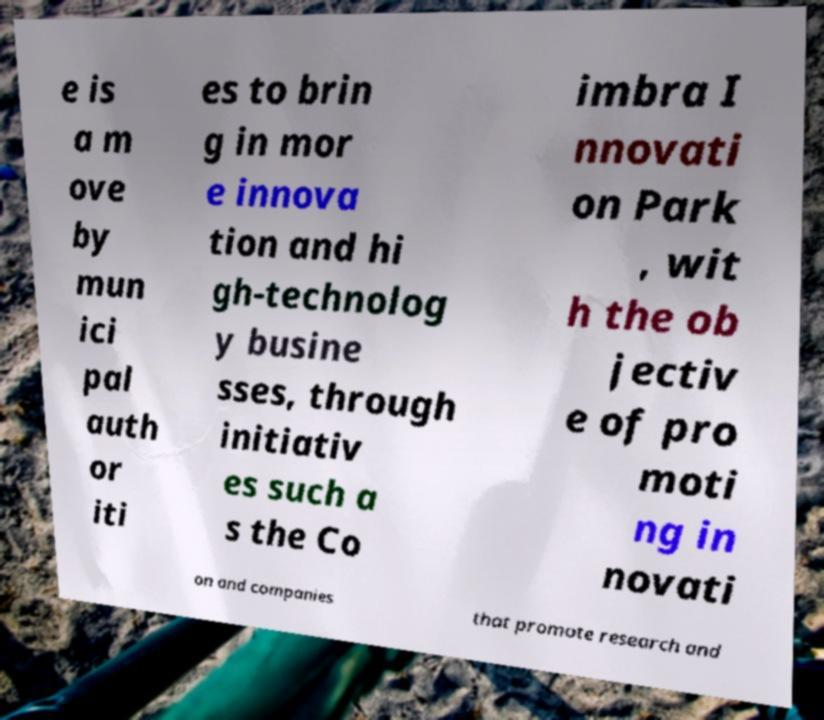Could you assist in decoding the text presented in this image and type it out clearly? e is a m ove by mun ici pal auth or iti es to brin g in mor e innova tion and hi gh-technolog y busine sses, through initiativ es such a s the Co imbra I nnovati on Park , wit h the ob jectiv e of pro moti ng in novati on and companies that promote research and 